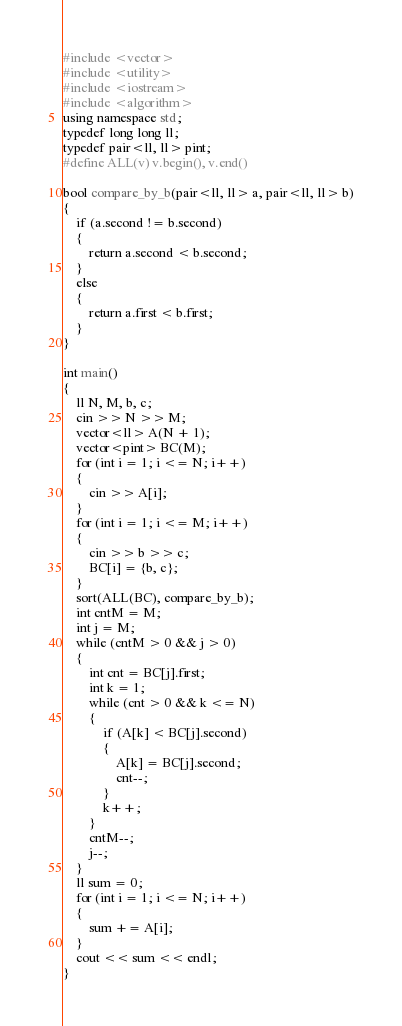<code> <loc_0><loc_0><loc_500><loc_500><_C++_>#include <vector>
#include <utility>
#include <iostream>
#include <algorithm>
using namespace std;
typedef long long ll;
typedef pair<ll, ll> pint;
#define ALL(v) v.begin(), v.end()

bool compare_by_b(pair<ll, ll> a, pair<ll, ll> b)
{
    if (a.second != b.second)
    {
        return a.second < b.second;
    }
    else
    {
        return a.first < b.first;
    }
}

int main()
{
    ll N, M, b, c;
    cin >> N >> M;
    vector<ll> A(N + 1);
    vector<pint> BC(M);
    for (int i = 1; i <= N; i++)
    {
        cin >> A[i];
    }
    for (int i = 1; i <= M; i++)
    {
        cin >> b >> c;
        BC[i] = {b, c};
    }
    sort(ALL(BC), compare_by_b);
    int cntM = M;
    int j = M;
    while (cntM > 0 && j > 0)
    {
        int cnt = BC[j].first;
        int k = 1;
        while (cnt > 0 && k <= N)
        {
            if (A[k] < BC[j].second)
            {
                A[k] = BC[j].second;
                cnt--;
            }
            k++;
        }
        cntM--;
        j--;
    }
    ll sum = 0;
    for (int i = 1; i <= N; i++)
    {
        sum += A[i];
    }
    cout << sum << endl;
}
</code> 